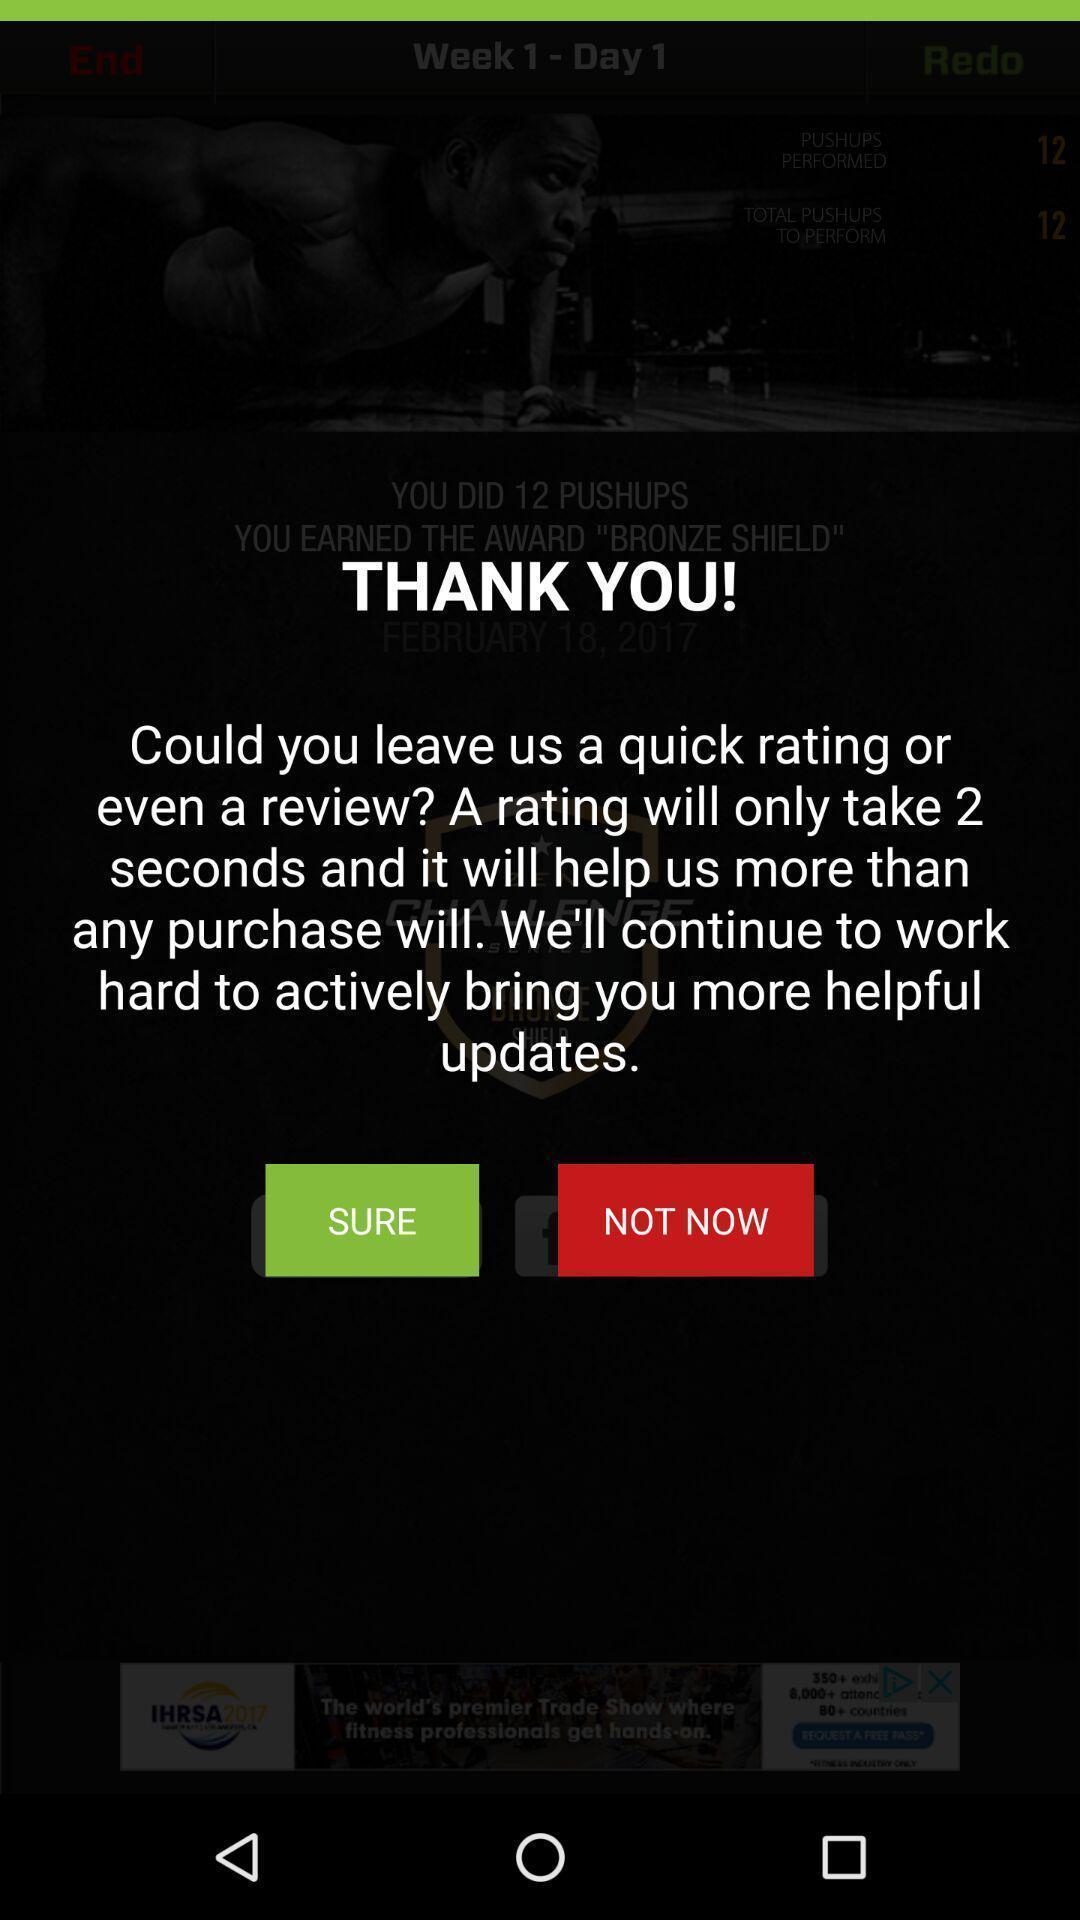What details can you identify in this image? Screen displays thank you message. 